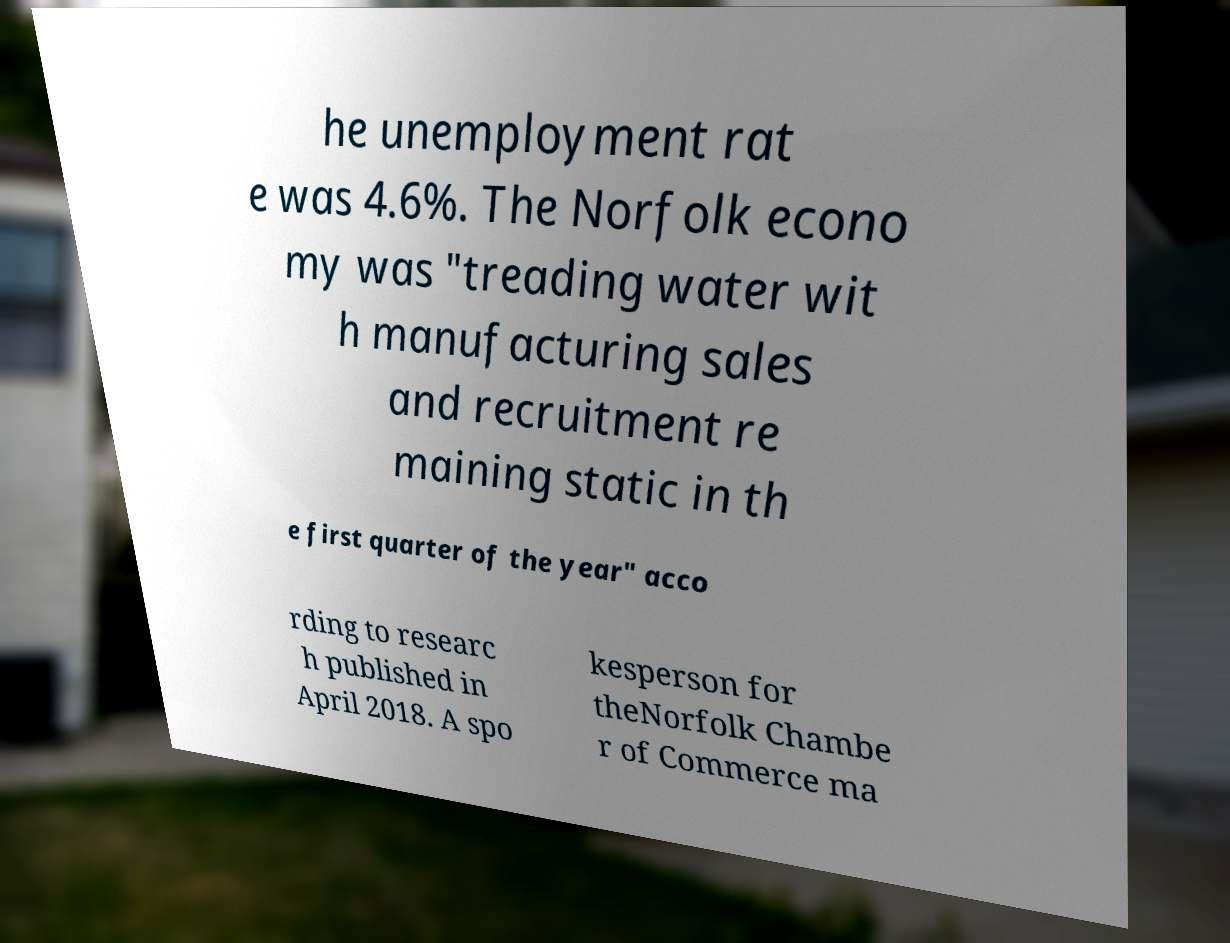Please read and relay the text visible in this image. What does it say? he unemployment rat e was 4.6%. The Norfolk econo my was "treading water wit h manufacturing sales and recruitment re maining static in th e first quarter of the year" acco rding to researc h published in April 2018. A spo kesperson for theNorfolk Chambe r of Commerce ma 